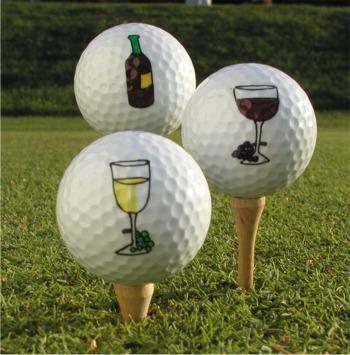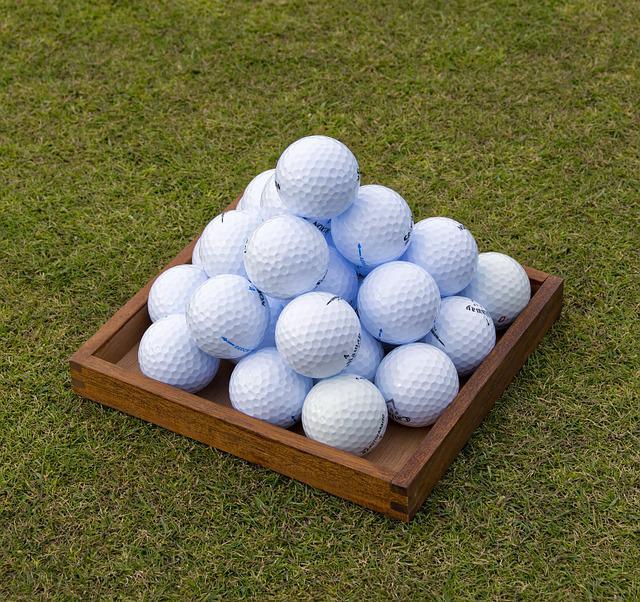The first image is the image on the left, the second image is the image on the right. Considering the images on both sides, is "An image shows a club right next to a golf ball." valid? Answer yes or no. No. The first image is the image on the left, the second image is the image on the right. Examine the images to the left and right. Is the description "One of the images contain a golf ball right next to a golf club." accurate? Answer yes or no. No. 